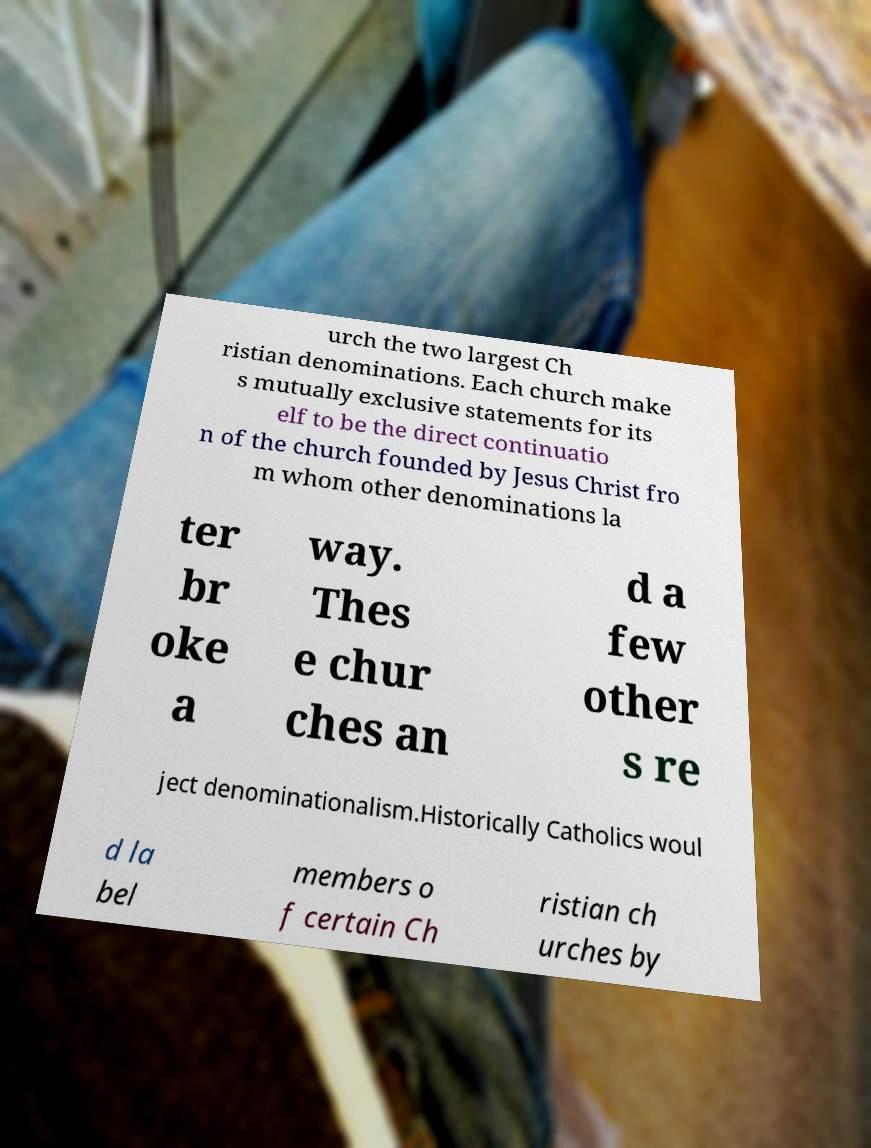I need the written content from this picture converted into text. Can you do that? urch the two largest Ch ristian denominations. Each church make s mutually exclusive statements for its elf to be the direct continuatio n of the church founded by Jesus Christ fro m whom other denominations la ter br oke a way. Thes e chur ches an d a few other s re ject denominationalism.Historically Catholics woul d la bel members o f certain Ch ristian ch urches by 